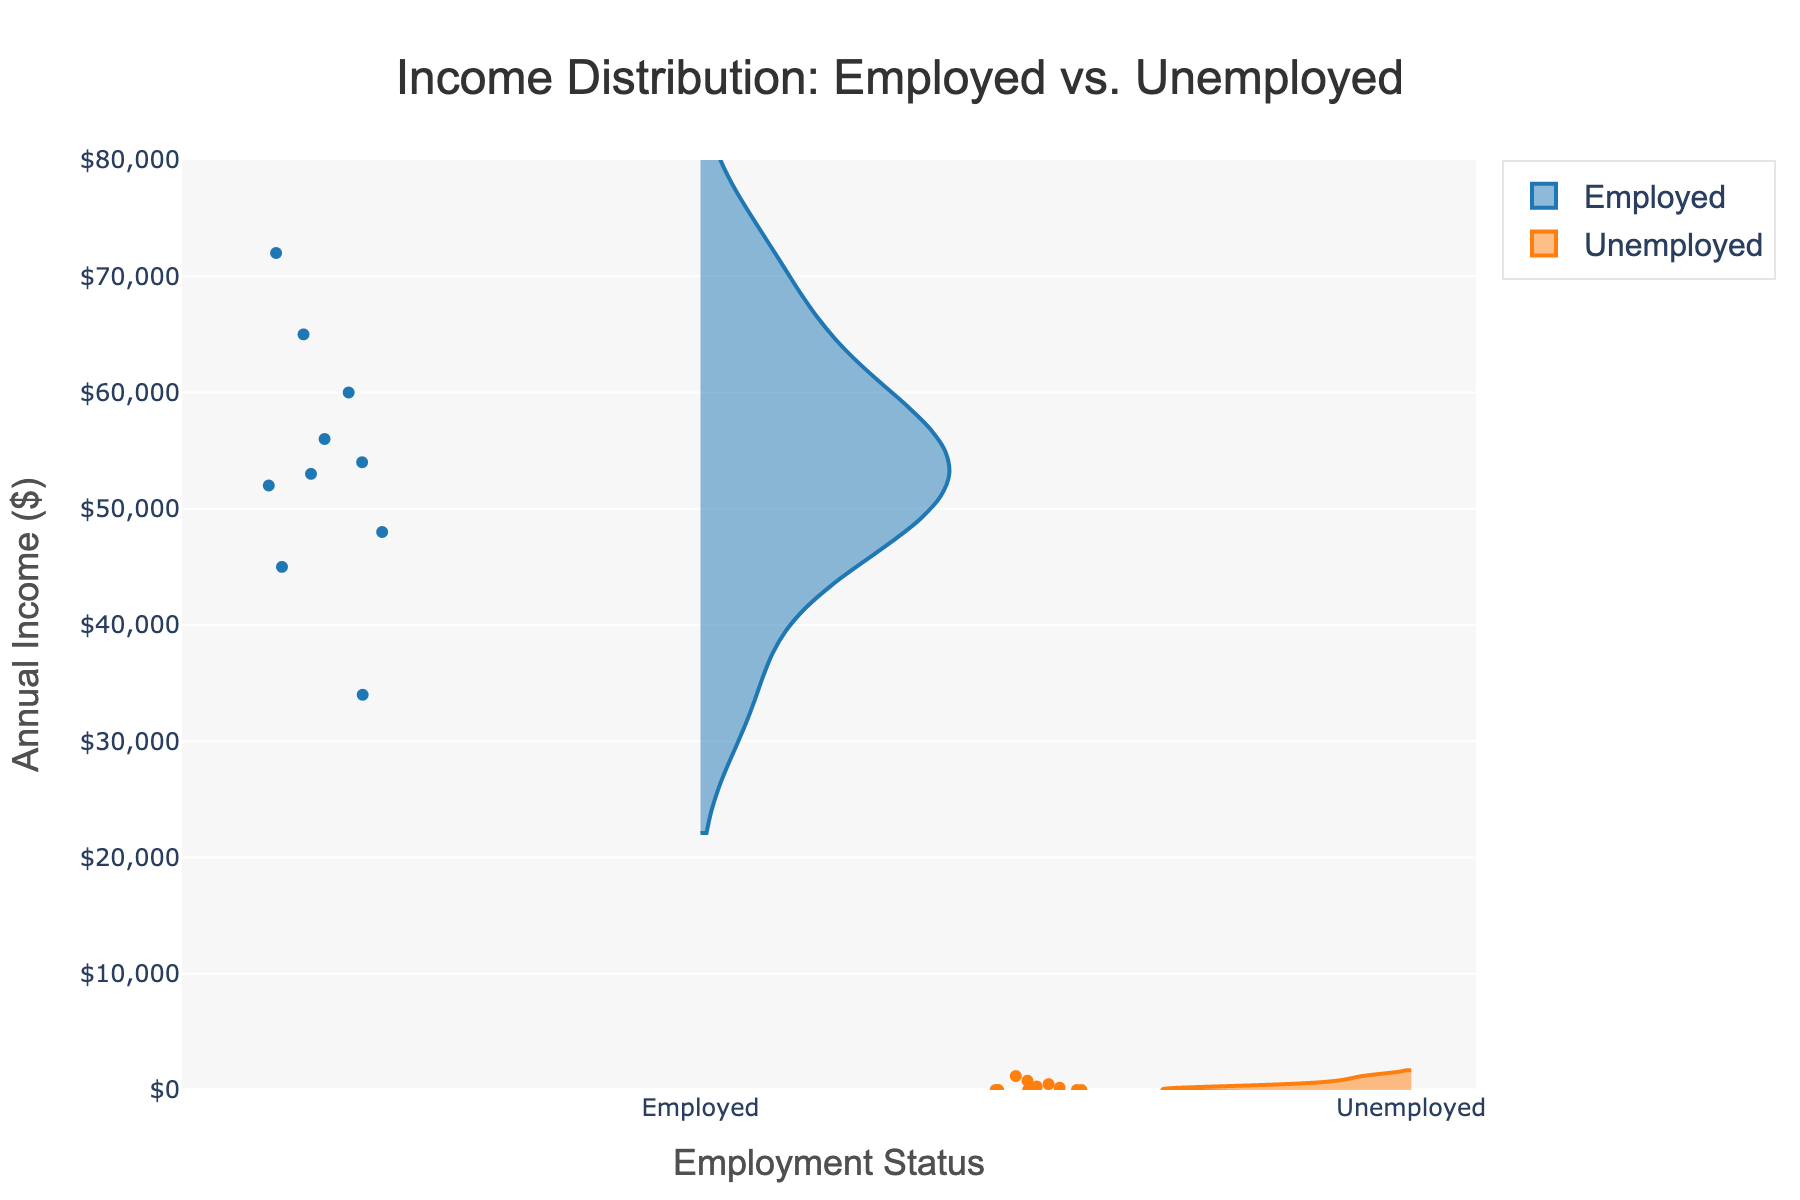What is the title of the plot? The title is located at the top center of the plot. It is a text label that summarizes the main focus of the visual representation.
Answer: Income Distribution: Employed vs. Unemployed What does the y-axis represent? The y-axis, labeled "Annual Income ($)," displays the annual income values. It helps in understanding the range and distribution of incomes for both employed and unemployed individuals.
Answer: Annual Income ($) Which color is used to represent employed individuals? In the plot, the employed individuals are represented using a blueish color. This color differentiates them from the unemployed group.
Answer: Blue How many unemployed individuals have an income of zero? By observing the violin plot for the unemployed group, you can count the number of points at the zero income level. These points indicate unemployed individuals with zero income.
Answer: 6 What is the range of income for employed individuals? The range is determined by identifying the lowest and highest values on the y-axis for the employed group. The lowest observed value is $34,000, and the highest is $72,000.
Answer: $34,000 to $72,000 Which group has a wider income distribution? A wider distribution is indicated by the width and spread of the violin plot. The employed group's distribution covers a broader span of values compared to the unemployed group.
Answer: Employed individuals What's the median income for employed individuals? The median can be estimated by examining the centerline of the employed group's violin plot, which shows the middle income value. The median value approximates $54,000.
Answer: $54,000 Does any unemployed individual earn more than $1,200? By observing the violin plot for unemployed individuals, the highest income value shown is $1,200. No points exceed this value on the plot.
Answer: No Compare the density of points between employed and unemployed at lower income levels. The density can be inferred by comparing the concentration of points near the lower end of the y-axis. The unemployed group has a higher density at low-income levels, especially around zero income.
Answer: Higher for unemployed What's the maximum income for unemployed individuals? The maximum income for unemployed individuals is indicated by the highest point on the violin plot for the unemployed group, which is $1,200.
Answer: $1,200 